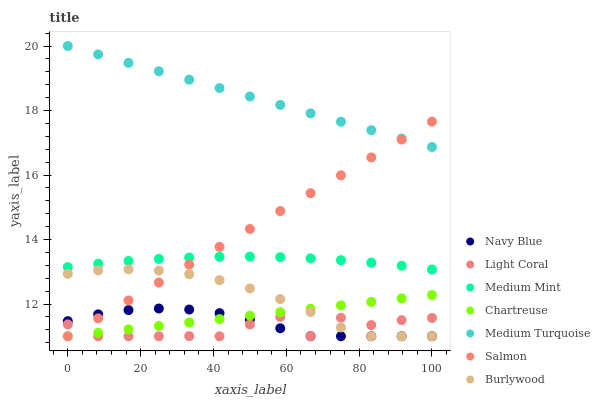Does Light Coral have the minimum area under the curve?
Answer yes or no. Yes. Does Medium Turquoise have the maximum area under the curve?
Answer yes or no. Yes. Does Burlywood have the minimum area under the curve?
Answer yes or no. No. Does Burlywood have the maximum area under the curve?
Answer yes or no. No. Is Chartreuse the smoothest?
Answer yes or no. Yes. Is Light Coral the roughest?
Answer yes or no. Yes. Is Burlywood the smoothest?
Answer yes or no. No. Is Burlywood the roughest?
Answer yes or no. No. Does Burlywood have the lowest value?
Answer yes or no. Yes. Does Medium Turquoise have the lowest value?
Answer yes or no. No. Does Medium Turquoise have the highest value?
Answer yes or no. Yes. Does Burlywood have the highest value?
Answer yes or no. No. Is Chartreuse less than Medium Turquoise?
Answer yes or no. Yes. Is Medium Turquoise greater than Chartreuse?
Answer yes or no. Yes. Does Salmon intersect Chartreuse?
Answer yes or no. Yes. Is Salmon less than Chartreuse?
Answer yes or no. No. Is Salmon greater than Chartreuse?
Answer yes or no. No. Does Chartreuse intersect Medium Turquoise?
Answer yes or no. No. 